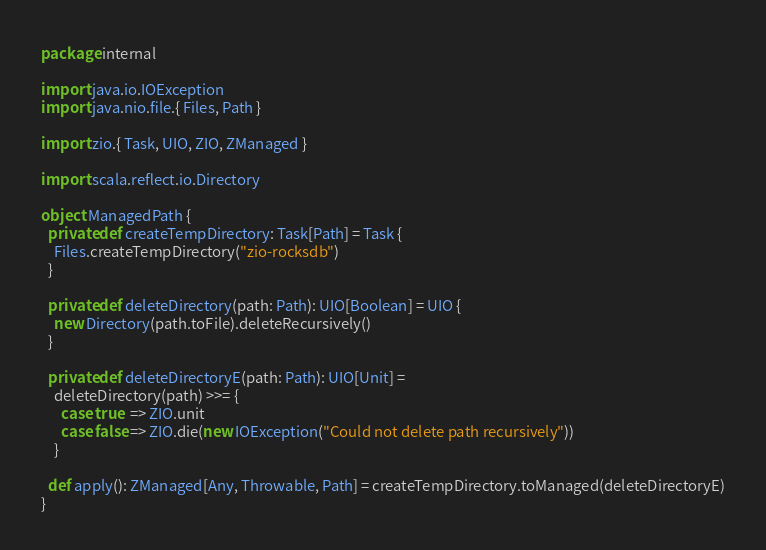Convert code to text. <code><loc_0><loc_0><loc_500><loc_500><_Scala_>package internal

import java.io.IOException
import java.nio.file.{ Files, Path }

import zio.{ Task, UIO, ZIO, ZManaged }

import scala.reflect.io.Directory

object ManagedPath {
  private def createTempDirectory: Task[Path] = Task {
    Files.createTempDirectory("zio-rocksdb")
  }

  private def deleteDirectory(path: Path): UIO[Boolean] = UIO {
    new Directory(path.toFile).deleteRecursively()
  }

  private def deleteDirectoryE(path: Path): UIO[Unit] =
    deleteDirectory(path) >>= {
      case true  => ZIO.unit
      case false => ZIO.die(new IOException("Could not delete path recursively"))
    }

  def apply(): ZManaged[Any, Throwable, Path] = createTempDirectory.toManaged(deleteDirectoryE)
}
</code> 